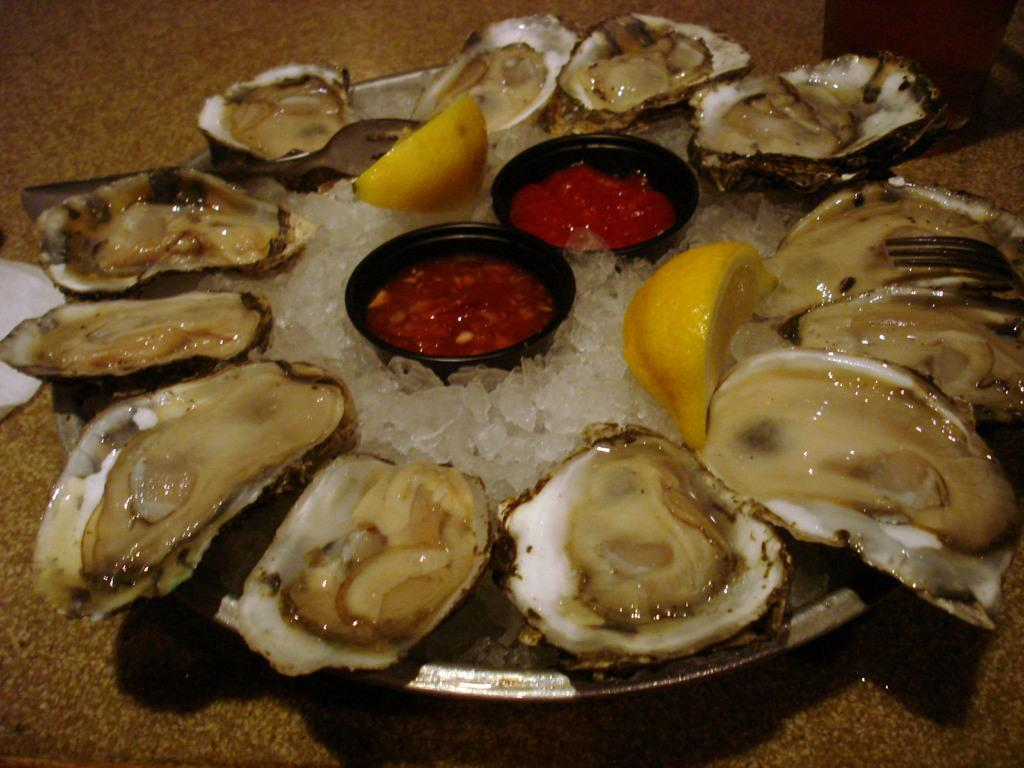What is on the plate that is visible in the image? There is food on a plate in the image. Where is the plate located in the image? The plate is on a surface in the image. What is the color of the surface the plate is on? The surface is brown in color. What can be seen on the left side of the image? There is an object on the left side of the image. What is the color of the object on the left side of the image? The object is white in color. What type of pipe is being used to cause the food to levitate in the image? There is no pipe or levitation of food present in the image; it shows food on a plate on a brown surface with a white object on the left side. 